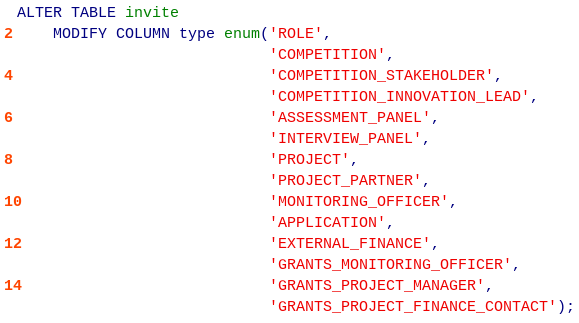Convert code to text. <code><loc_0><loc_0><loc_500><loc_500><_SQL_>ALTER TABLE invite
    MODIFY COLUMN type enum('ROLE',
                            'COMPETITION',
                            'COMPETITION_STAKEHOLDER',
                            'COMPETITION_INNOVATION_LEAD',
                            'ASSESSMENT_PANEL',
                            'INTERVIEW_PANEL',
                            'PROJECT',
                            'PROJECT_PARTNER',
                            'MONITORING_OFFICER',
                            'APPLICATION',
                            'EXTERNAL_FINANCE',
                            'GRANTS_MONITORING_OFFICER',
                            'GRANTS_PROJECT_MANAGER',
                            'GRANTS_PROJECT_FINANCE_CONTACT');</code> 